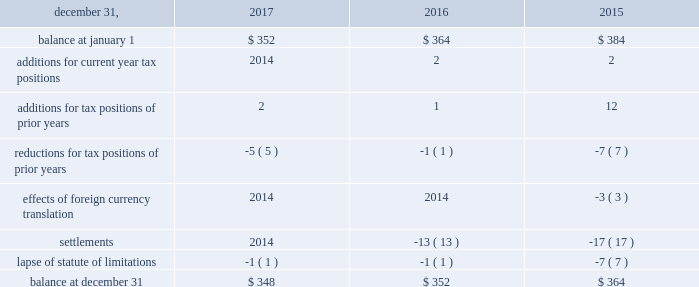The aes corporation notes to consolidated financial statements 2014 ( continued ) december 31 , 2017 , 2016 , and 2015 the total amount of unrecognized tax benefits anticipated to result in a net decrease to unrecognized tax benefits within 12 months of december 31 , 2017 is estimated to be between $ 5 million and $ 15 million , primarily relating to statute of limitation lapses and tax exam settlements .
The following is a reconciliation of the beginning and ending amounts of unrecognized tax benefits for the periods indicated ( in millions ) : .
The company and certain of its subsidiaries are currently under examination by the relevant taxing authorities for various tax years .
The company regularly assesses the potential outcome of these examinations in each of the taxing jurisdictions when determining the adequacy of the amount of unrecognized tax benefit recorded .
While it is often difficult to predict the final outcome or the timing of resolution of any particular uncertain tax position , we believe we have appropriately accrued for our uncertain tax benefits .
However , audit outcomes and the timing of audit settlements and future events that would impact our previously recorded unrecognized tax benefits and the range of anticipated increases or decreases in unrecognized tax benefits are subject to significant uncertainty .
It is possible that the ultimate outcome of current or future examinations may exceed our provision for current unrecognized tax benefits in amounts that could be material , but cannot be estimated as of december 31 , 2017 .
Our effective tax rate and net income in any given future period could therefore be materially impacted .
21 .
Discontinued operations due to a portfolio evaluation in the first half of 2016 , management decided to pursue a strategic shift of its distribution companies in brazil , sul and eletropaulo , to reduce the company's exposure to the brazilian distribution market .
Eletropaulo 2014 in november 2017 , eletropaulo converted its preferred shares into ordinary shares and transitioned the listing of those shares into the novo mercado , which is a listing segment of the brazilian stock exchange with the highest standards of corporate governance .
Upon conversion of the preferred shares into ordinary shares , aes no longer controlled eletropaulo , but maintained significant influence over the business .
As a result , the company deconsolidated eletropaulo .
After deconsolidation , the company's 17% ( 17 % ) ownership interest is reflected as an equity method investment .
The company recorded an after-tax loss on deconsolidation of $ 611 million , which primarily consisted of $ 455 million related to cumulative translation losses and $ 243 million related to pension losses reclassified from aocl .
In december 2017 , all the remaining criteria were met for eletropaulo to qualify as a discontinued operation .
Therefore , its results of operations and financial position were reported as such in the consolidated financial statements for all periods presented .
Eletropaulo's pre-tax loss attributable to aes , including the loss on deconsolidation , for the years ended december 31 , 2017 and 2016 was $ 633 million and $ 192 million , respectively .
Eletropaulo's pre-tax income attributable to aes for the year ended december 31 , 2015 was $ 73 million .
Prior to its classification as discontinued operations , eletropaulo was reported in the brazil sbu reportable segment .
Sul 2014 the company executed an agreement for the sale of sul , a wholly-owned subsidiary , in june 2016 .
The results of operations and financial position of sul are reported as discontinued operations in the consolidated financial statements for all periods presented .
Upon meeting the held-for-sale criteria , the company recognized an after-tax loss of $ 382 million comprised of a pre-tax impairment charge of $ 783 million , offset by a tax benefit of $ 266 million related to the impairment of the sul long lived assets and a tax benefit of $ 135 million for deferred taxes related to the investment in sul .
Prior to the impairment charge , the carrying value of the sul asset group of $ 1.6 billion was greater than its approximate fair value less costs to sell .
However , the impairment charge was limited to the carrying value of the long lived assets of the sul disposal group .
On october 31 , 2016 , the company completed the sale of sul and received final proceeds less costs to sell of $ 484 million , excluding contingent consideration .
Upon disposal of sul , the company incurred an additional after-tax .
What percent of the after-tax loss on deconsolidation hit ordinary income? 
Computations: (243 / 611)
Answer: 0.39771. The aes corporation notes to consolidated financial statements 2014 ( continued ) december 31 , 2017 , 2016 , and 2015 the total amount of unrecognized tax benefits anticipated to result in a net decrease to unrecognized tax benefits within 12 months of december 31 , 2017 is estimated to be between $ 5 million and $ 15 million , primarily relating to statute of limitation lapses and tax exam settlements .
The following is a reconciliation of the beginning and ending amounts of unrecognized tax benefits for the periods indicated ( in millions ) : .
The company and certain of its subsidiaries are currently under examination by the relevant taxing authorities for various tax years .
The company regularly assesses the potential outcome of these examinations in each of the taxing jurisdictions when determining the adequacy of the amount of unrecognized tax benefit recorded .
While it is often difficult to predict the final outcome or the timing of resolution of any particular uncertain tax position , we believe we have appropriately accrued for our uncertain tax benefits .
However , audit outcomes and the timing of audit settlements and future events that would impact our previously recorded unrecognized tax benefits and the range of anticipated increases or decreases in unrecognized tax benefits are subject to significant uncertainty .
It is possible that the ultimate outcome of current or future examinations may exceed our provision for current unrecognized tax benefits in amounts that could be material , but cannot be estimated as of december 31 , 2017 .
Our effective tax rate and net income in any given future period could therefore be materially impacted .
21 .
Discontinued operations due to a portfolio evaluation in the first half of 2016 , management decided to pursue a strategic shift of its distribution companies in brazil , sul and eletropaulo , to reduce the company's exposure to the brazilian distribution market .
Eletropaulo 2014 in november 2017 , eletropaulo converted its preferred shares into ordinary shares and transitioned the listing of those shares into the novo mercado , which is a listing segment of the brazilian stock exchange with the highest standards of corporate governance .
Upon conversion of the preferred shares into ordinary shares , aes no longer controlled eletropaulo , but maintained significant influence over the business .
As a result , the company deconsolidated eletropaulo .
After deconsolidation , the company's 17% ( 17 % ) ownership interest is reflected as an equity method investment .
The company recorded an after-tax loss on deconsolidation of $ 611 million , which primarily consisted of $ 455 million related to cumulative translation losses and $ 243 million related to pension losses reclassified from aocl .
In december 2017 , all the remaining criteria were met for eletropaulo to qualify as a discontinued operation .
Therefore , its results of operations and financial position were reported as such in the consolidated financial statements for all periods presented .
Eletropaulo's pre-tax loss attributable to aes , including the loss on deconsolidation , for the years ended december 31 , 2017 and 2016 was $ 633 million and $ 192 million , respectively .
Eletropaulo's pre-tax income attributable to aes for the year ended december 31 , 2015 was $ 73 million .
Prior to its classification as discontinued operations , eletropaulo was reported in the brazil sbu reportable segment .
Sul 2014 the company executed an agreement for the sale of sul , a wholly-owned subsidiary , in june 2016 .
The results of operations and financial position of sul are reported as discontinued operations in the consolidated financial statements for all periods presented .
Upon meeting the held-for-sale criteria , the company recognized an after-tax loss of $ 382 million comprised of a pre-tax impairment charge of $ 783 million , offset by a tax benefit of $ 266 million related to the impairment of the sul long lived assets and a tax benefit of $ 135 million for deferred taxes related to the investment in sul .
Prior to the impairment charge , the carrying value of the sul asset group of $ 1.6 billion was greater than its approximate fair value less costs to sell .
However , the impairment charge was limited to the carrying value of the long lived assets of the sul disposal group .
On october 31 , 2016 , the company completed the sale of sul and received final proceeds less costs to sell of $ 484 million , excluding contingent consideration .
Upon disposal of sul , the company incurred an additional after-tax .
What was the net change in millions in unrecognized tax benefits from 2016 to 2017? 
Computations: (348 - 352)
Answer: -4.0. 